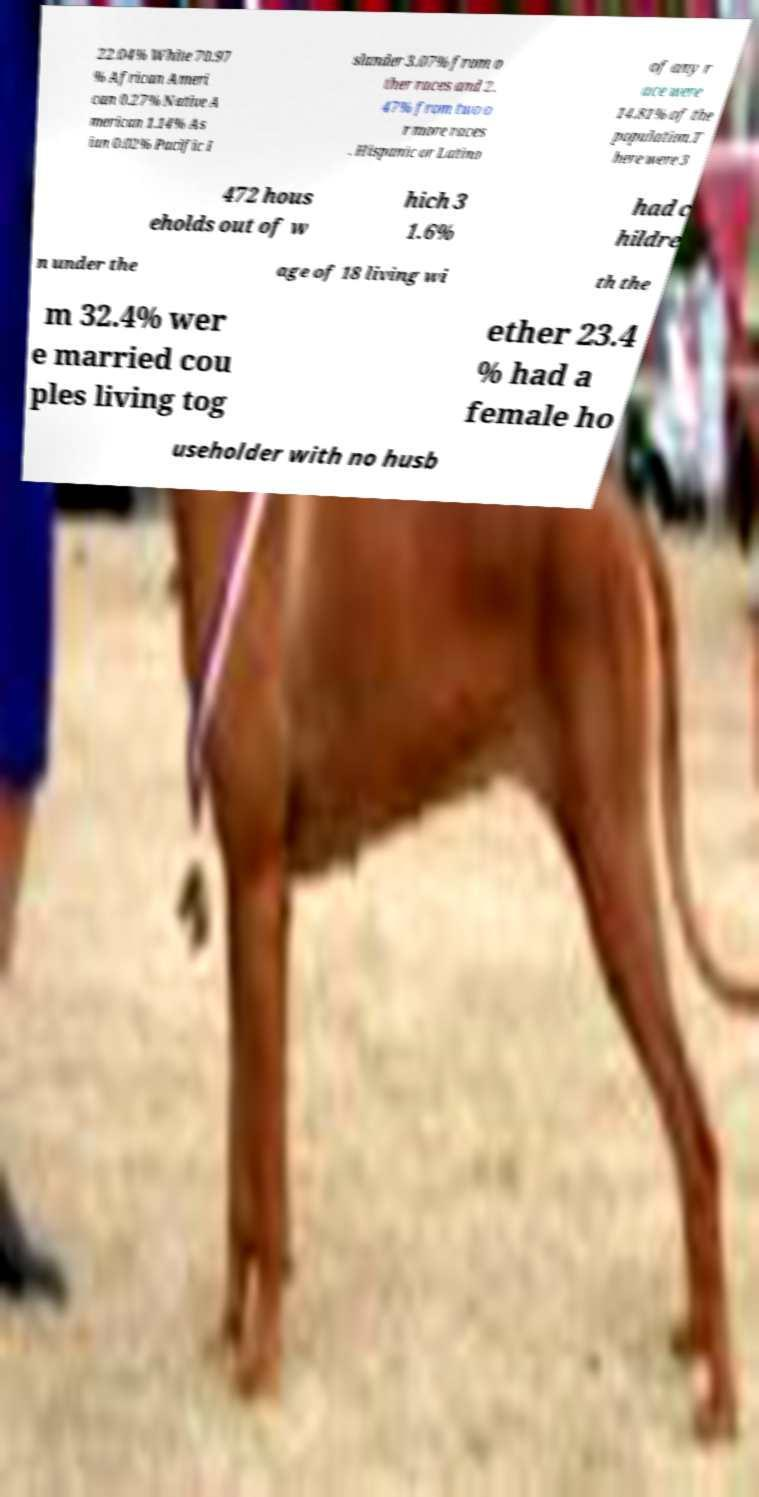Can you accurately transcribe the text from the provided image for me? 22.04% White 70.97 % African Ameri can 0.27% Native A merican 1.14% As ian 0.02% Pacific I slander 3.07% from o ther races and 2. 47% from two o r more races . Hispanic or Latino of any r ace were 14.81% of the population.T here were 3 472 hous eholds out of w hich 3 1.6% had c hildre n under the age of 18 living wi th the m 32.4% wer e married cou ples living tog ether 23.4 % had a female ho useholder with no husb 